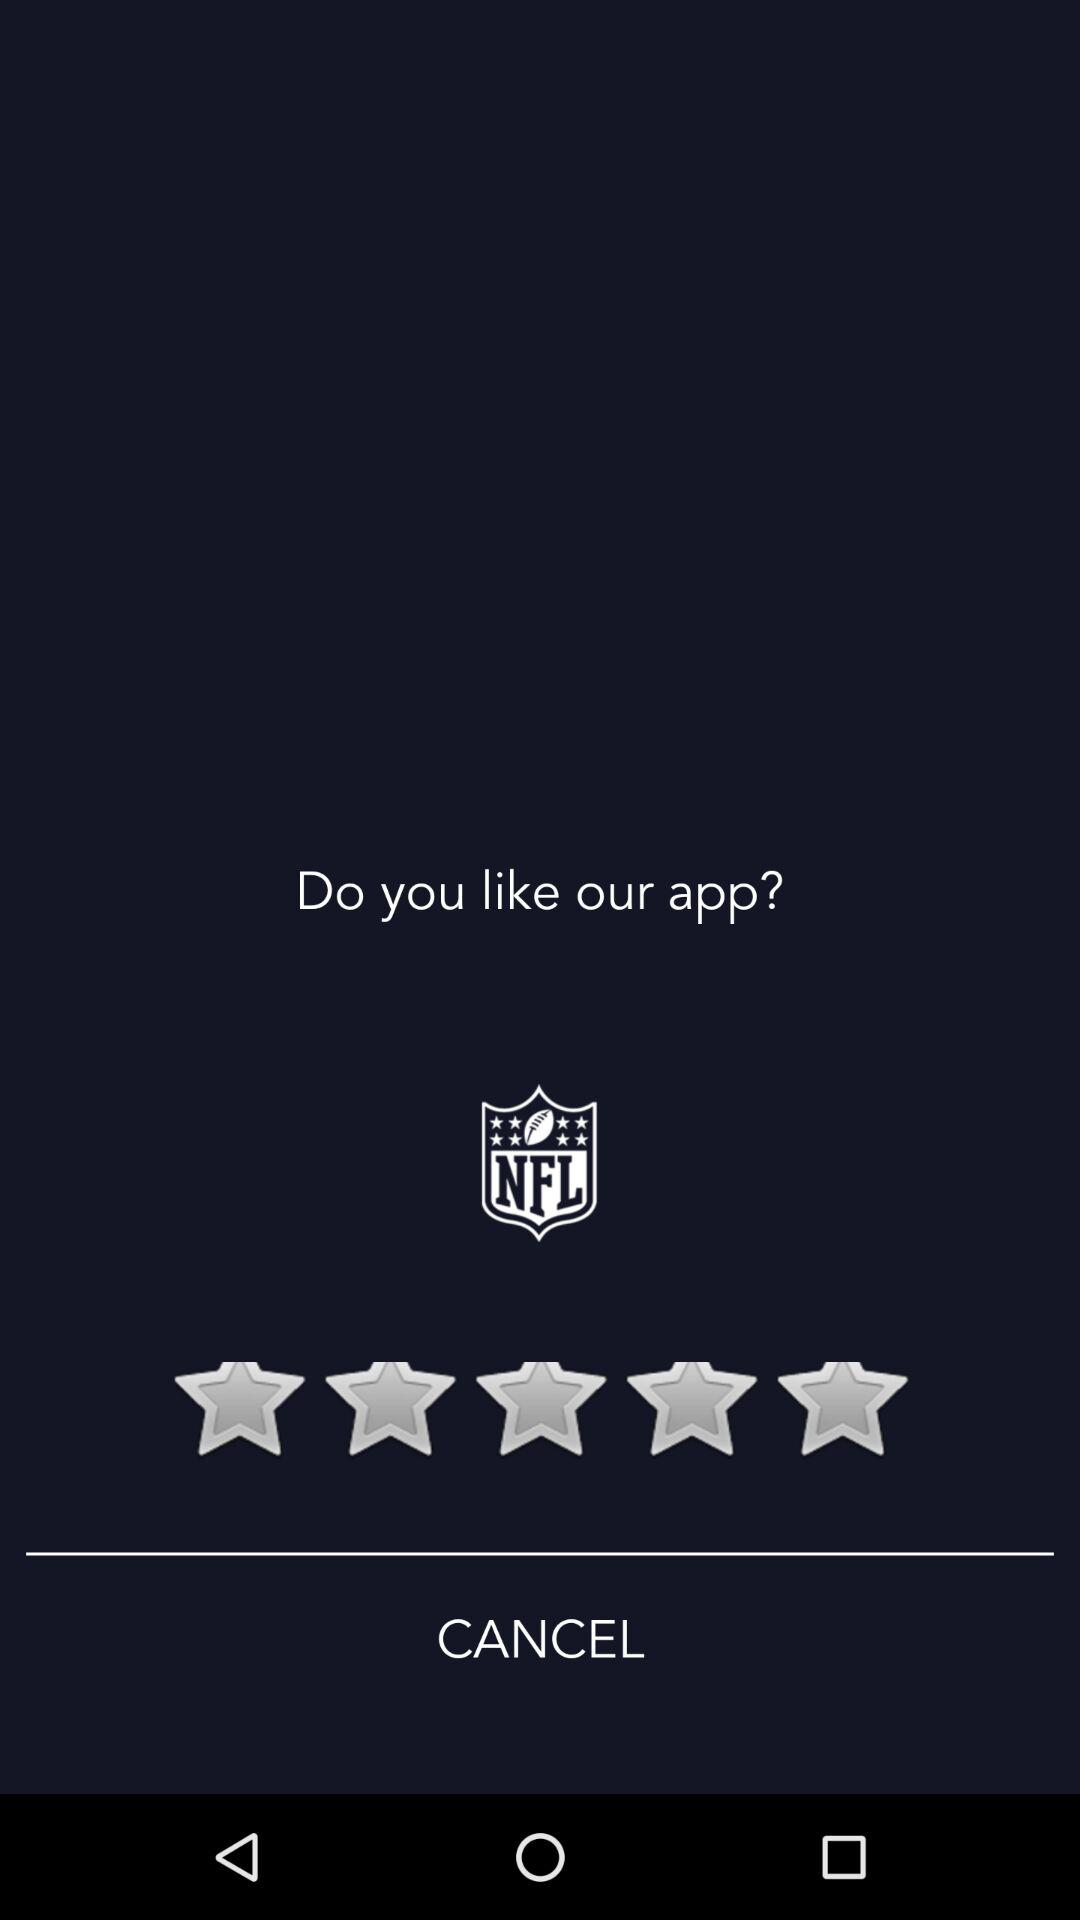How many people follow the application?
When the provided information is insufficient, respond with <no answer>. <no answer> 